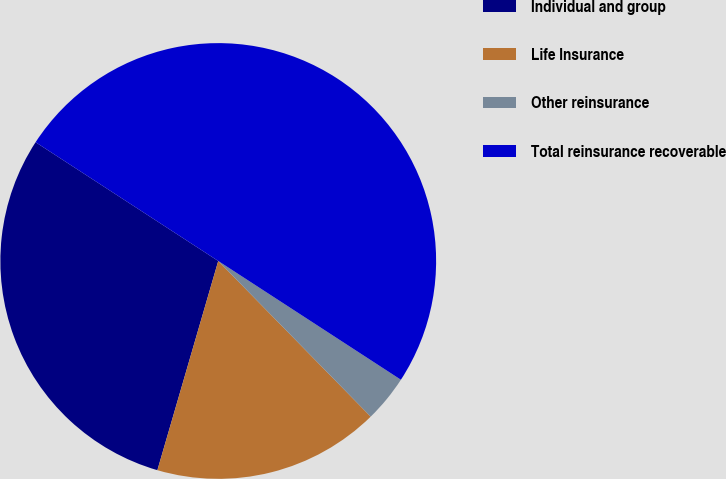Convert chart to OTSL. <chart><loc_0><loc_0><loc_500><loc_500><pie_chart><fcel>Individual and group<fcel>Life Insurance<fcel>Other reinsurance<fcel>Total reinsurance recoverable<nl><fcel>29.67%<fcel>16.84%<fcel>3.49%<fcel>50.0%<nl></chart> 